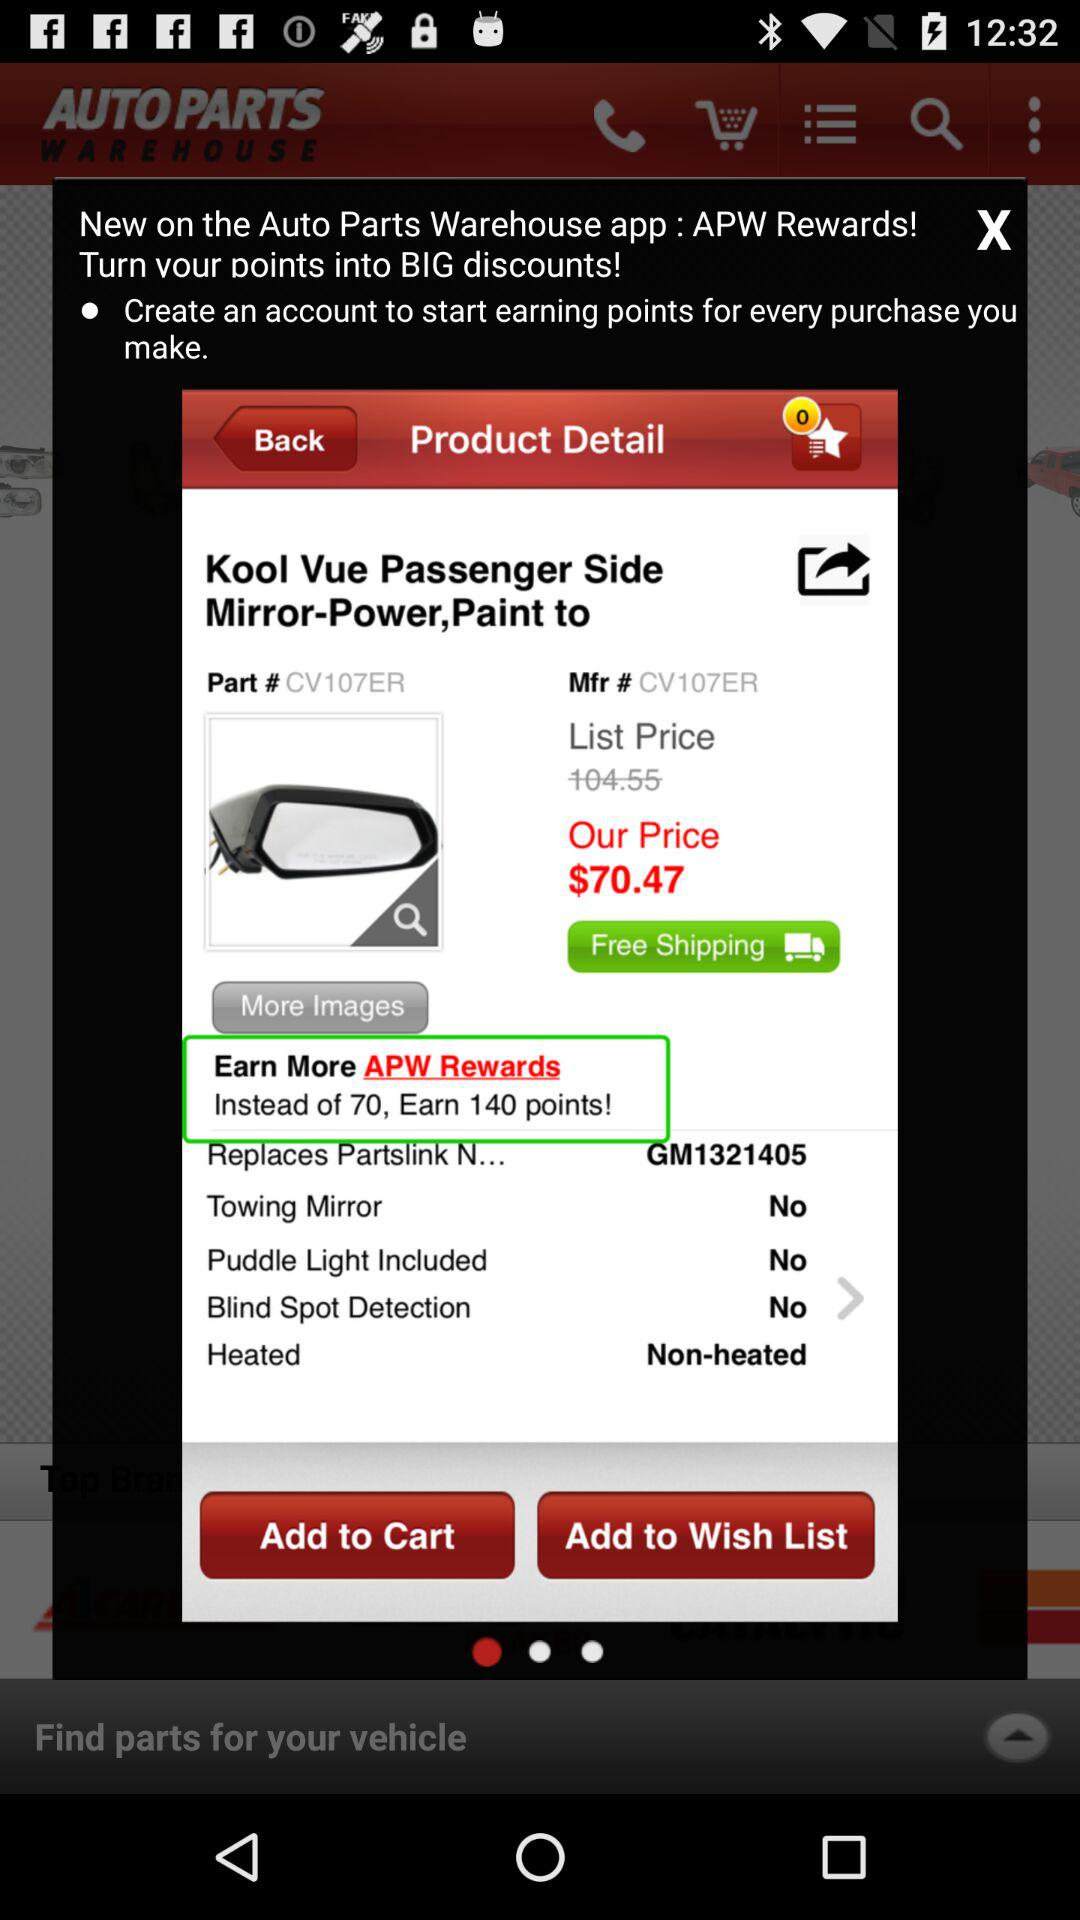How many 'APW Rewards' are available for this product?
Answer the question using a single word or phrase. 140 